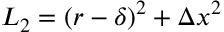Convert formula to latex. <formula><loc_0><loc_0><loc_500><loc_500>L _ { 2 } = \left ( r - \delta \right ) ^ { 2 } + \Delta x ^ { 2 }</formula> 